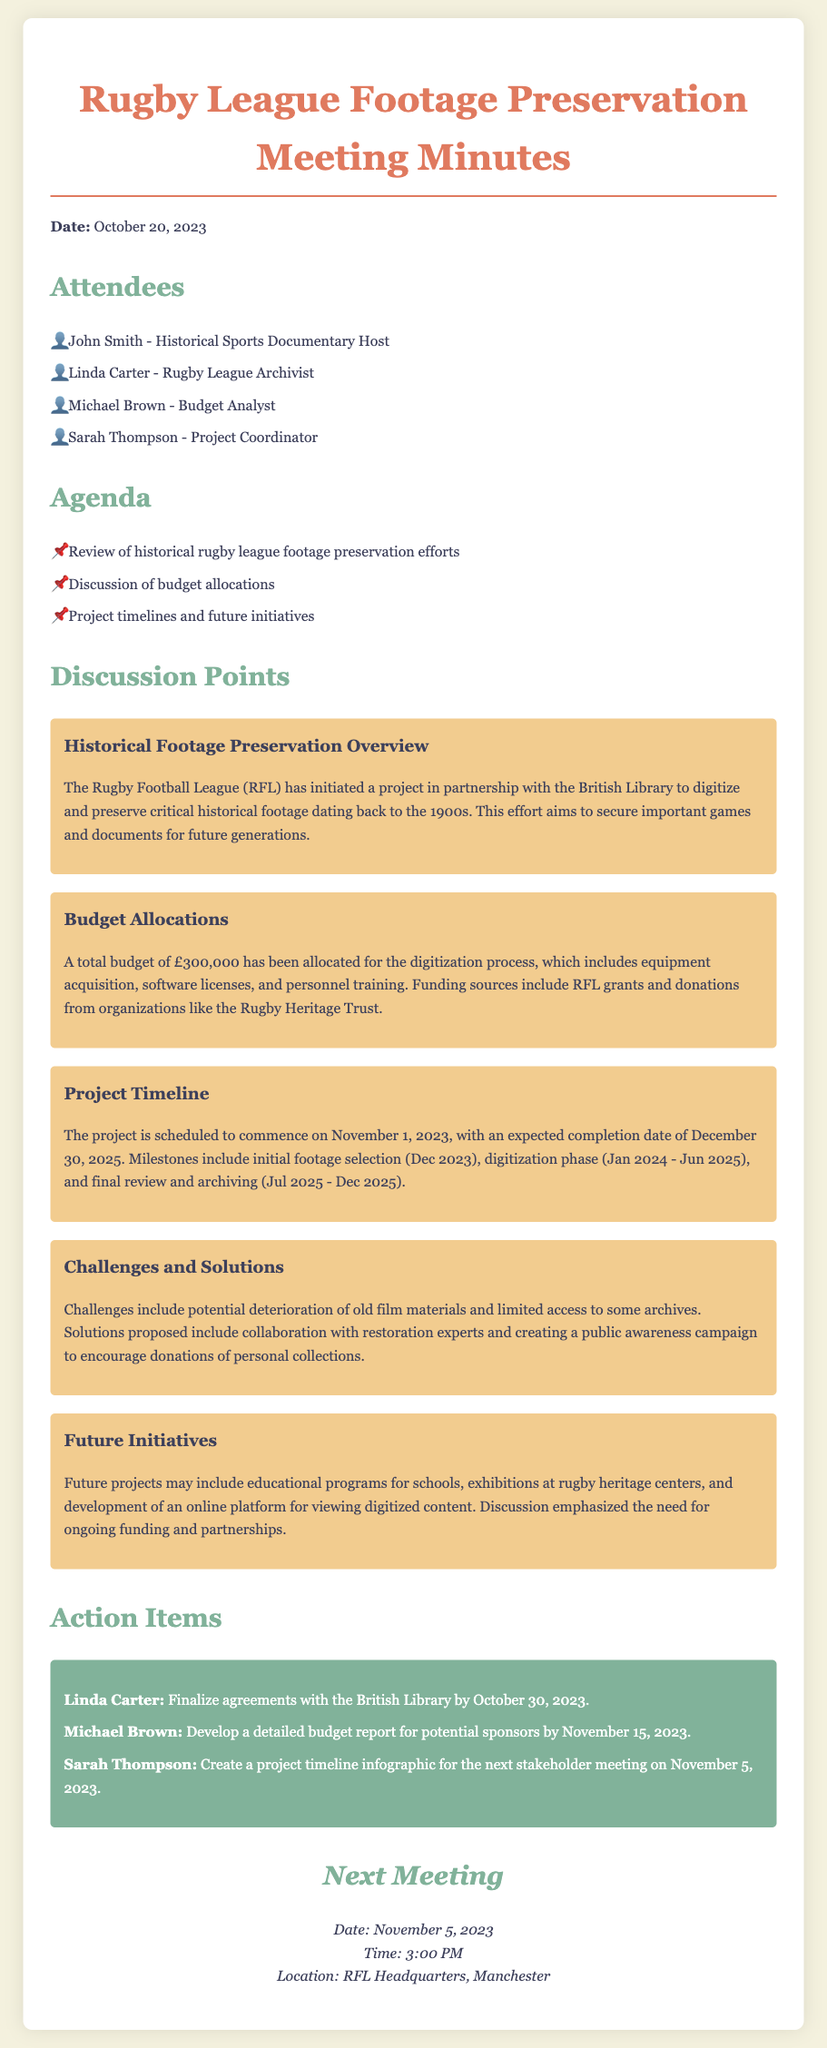What is the date of the meeting? The date of the meeting is provided in the opening section of the document.
Answer: October 20, 2023 Who is the Rugby League Archivist? This information is found under the attendees section, listing the participants of the meeting.
Answer: Linda Carter How much budget is allocated for the digitization process? The budget is specifically mentioned in the budget allocations section of the discussion.
Answer: £300,000 When is the project expected to commence? The project timeline section gives the starting date for the project.
Answer: November 1, 2023 What is one of the challenges identified in the meeting? The challenges are discussed in the challenges and solutions section, outlining issues faced in the project.
Answer: Deterioration of old film materials What will happen in December 2023? The timeline outlines significant milestones planned for the project.
Answer: Initial footage selection Who needs to finalize agreements with the British Library? The action items specify who is responsible for certain tasks discussed in the meeting.
Answer: Linda Carter What is planned for the next stakeholder meeting? The next meeting section indicates the date and time for the upcoming discussion.
Answer: November 5, 2023 What funding sources are mentioned for the project? The budget allocations part lists the sources of funding for the digitization project.
Answer: RFL grants and donations from organizations like the Rugby Heritage Trust 